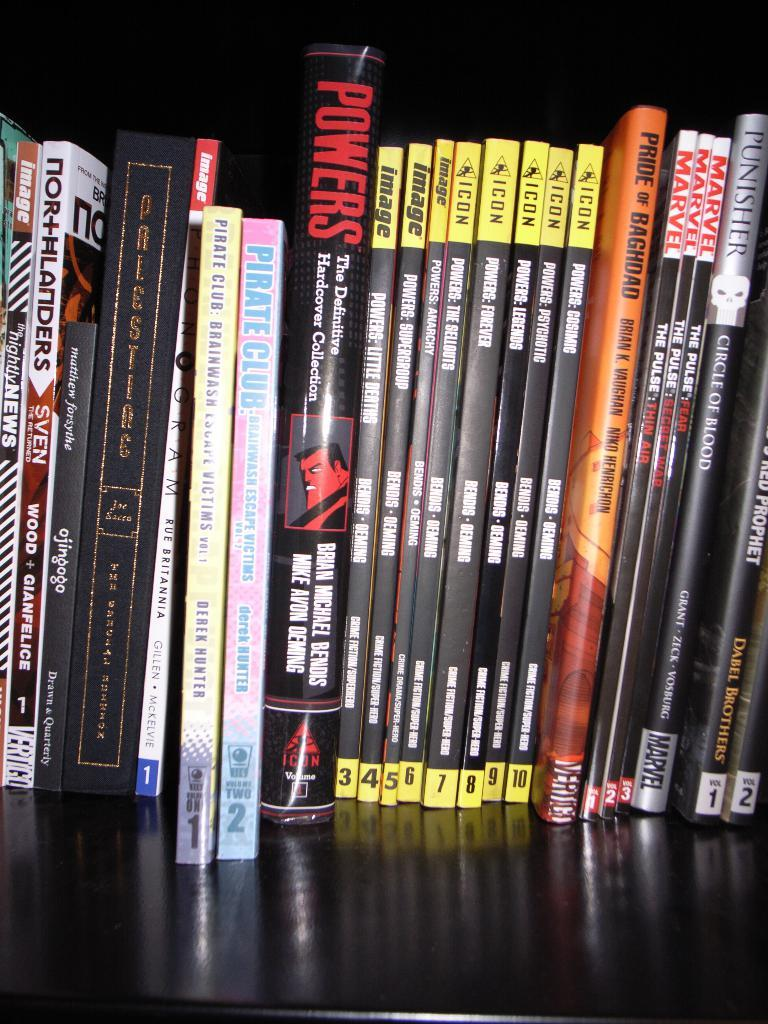<image>
Share a concise interpretation of the image provided. a black book with red writing that says powers 